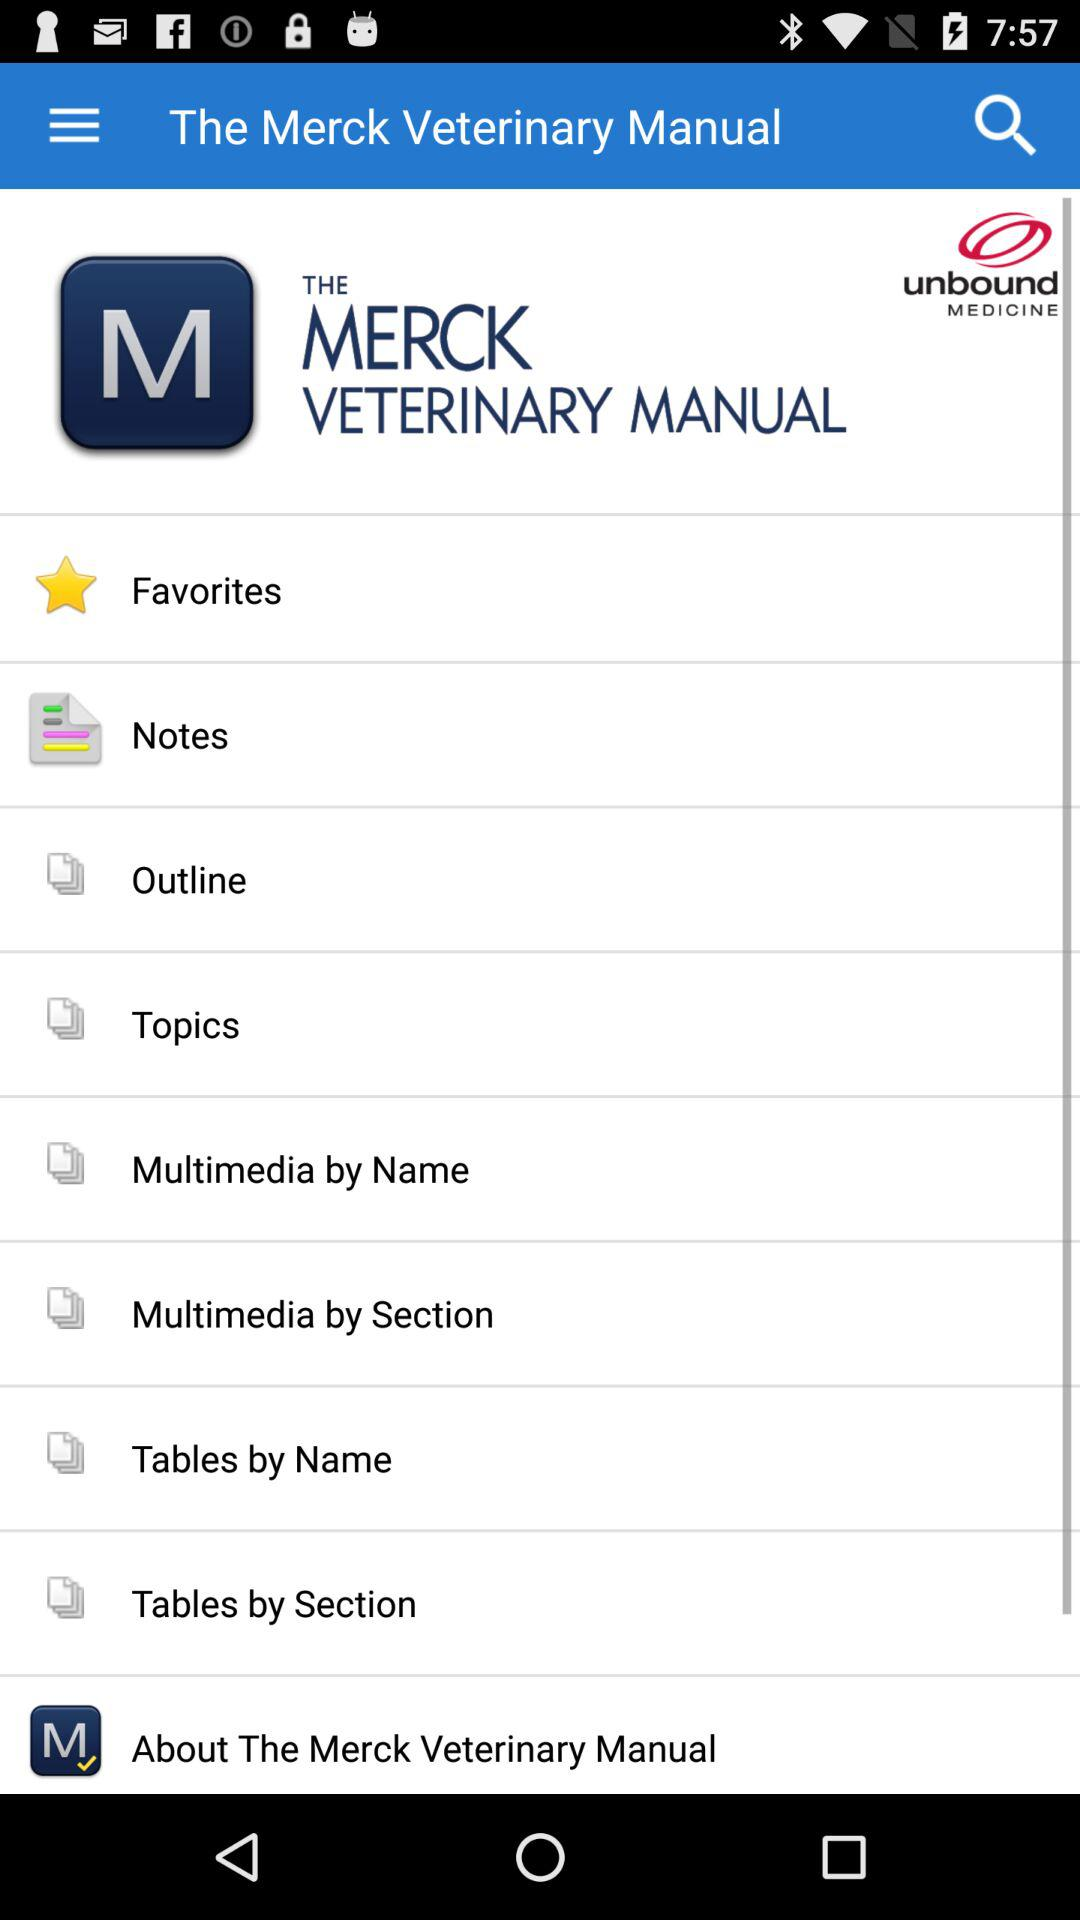What is the name of the application? The name of the application is "The Merck Veterinary Manual". 